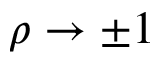<formula> <loc_0><loc_0><loc_500><loc_500>\rho \to \pm 1</formula> 